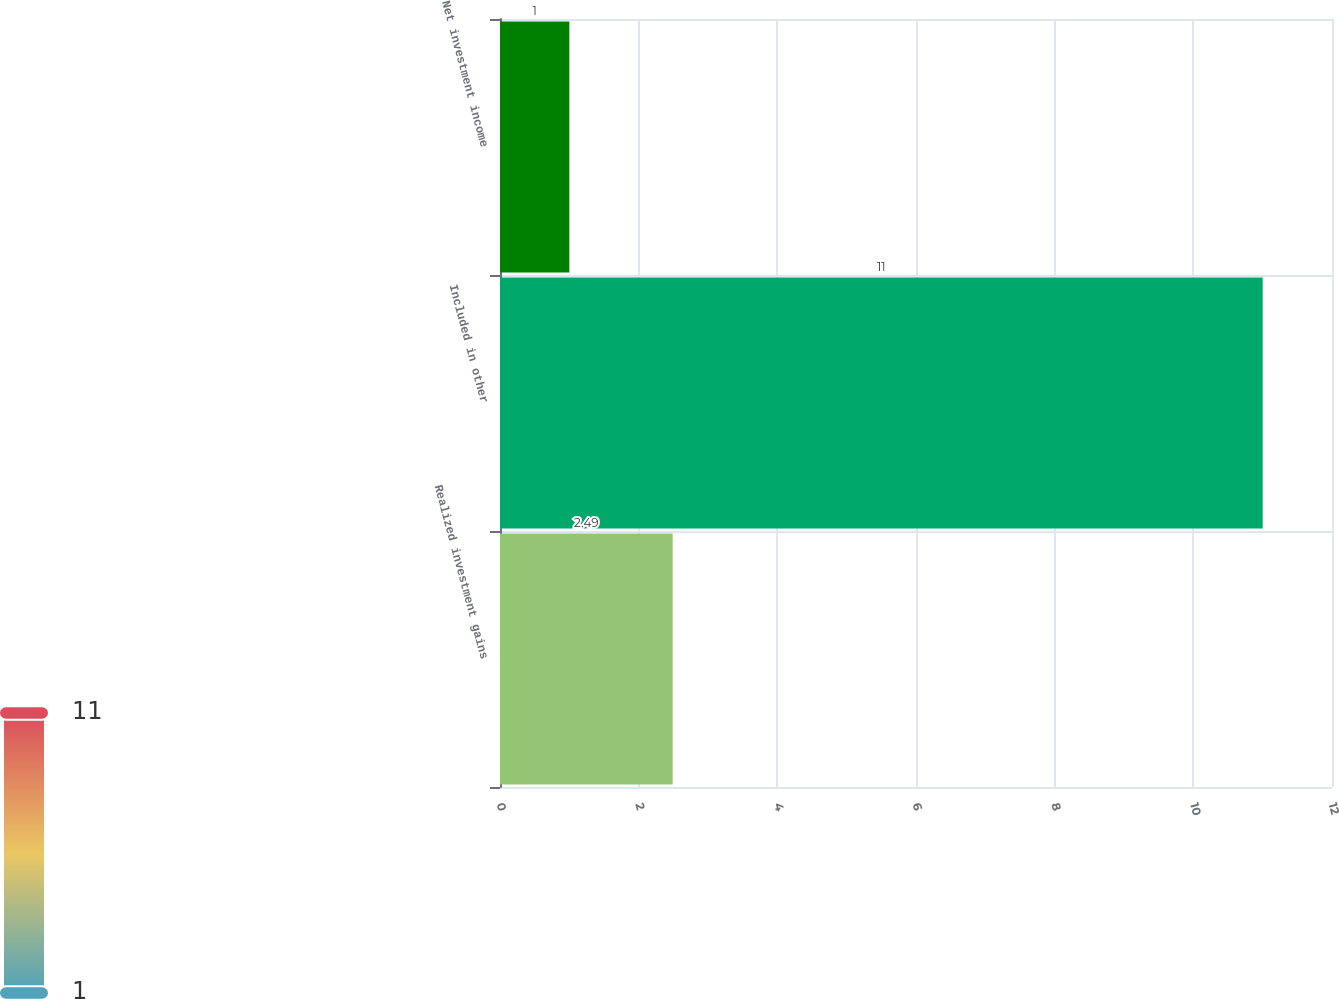Convert chart to OTSL. <chart><loc_0><loc_0><loc_500><loc_500><bar_chart><fcel>Realized investment gains<fcel>Included in other<fcel>Net investment income<nl><fcel>2.49<fcel>11<fcel>1<nl></chart> 